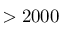<formula> <loc_0><loc_0><loc_500><loc_500>> 2 0 0 0</formula> 